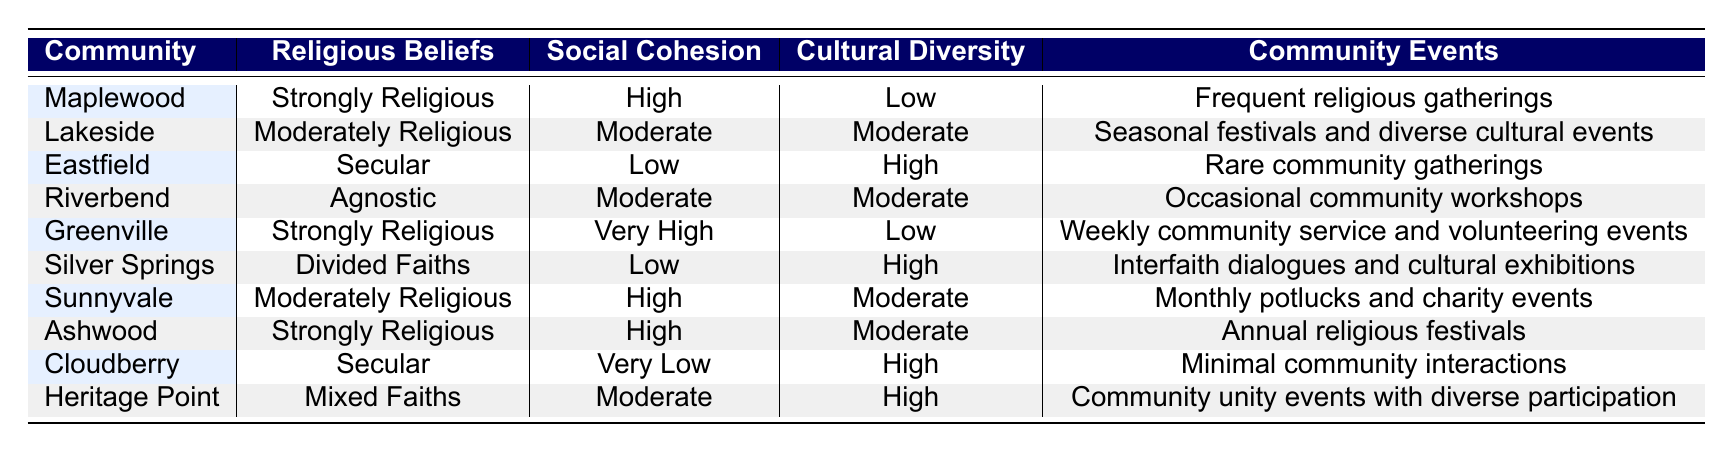What is the social cohesion level in Maplewood? According to the table, Maplewood has a social cohesion level of "High".
Answer: High Which community has the highest level of social cohesion? Greenville has the highest level of social cohesion at "Very High".
Answer: Greenville How many communities have a low level of social cohesion? Looking at the table, Eastfield, Silver Springs, and Cloudberry each have a "Low" level of social cohesion, totaling three communities.
Answer: 3 Is there any community with mixed faiths that has high social cohesion? No, the only community with mixed faiths is Heritage Point, which has a "Moderate" level of social cohesion.
Answer: No What is the average level of cultural diversity for communities with strongly religious beliefs? The communities with strongly religious beliefs are Maplewood, Greenville, and Ashwood. They have cultural diversity levels of "Low", "Low", and "Moderate", respectively. If we assign numerical values (Low=1, Moderate=2), we find the average: (1 + 1 + 2) / 3 = 1.33, which is interpreted as Low.
Answer: Low Which religious belief corresponds with the lowest social cohesion? Cloudberry, which holds secular beliefs, has the lowest social cohesion rating of "Very Low".
Answer: Secular What type of community events are held in Sunnyvale? Sunnyvale hosts "Monthly potlucks and charity events" as community events.
Answer: Monthly potlucks and charity events How many communities have cultural diversity rated as high? The communities with high cultural diversity are Eastfield, Silver Springs, Cloudberry, and Heritage Point, totaling four communities.
Answer: 4 What is the social cohesion of the community with the highest cultural diversity? Eastfield has high cultural diversity and a social cohesion level of "Low".
Answer: Low Are there any communities that have both a moderate level of social cohesion and moderate cultural diversity? Yes, Lakeside and Riverbend both exhibit moderate levels for social cohesion and cultural diversity.
Answer: Yes 